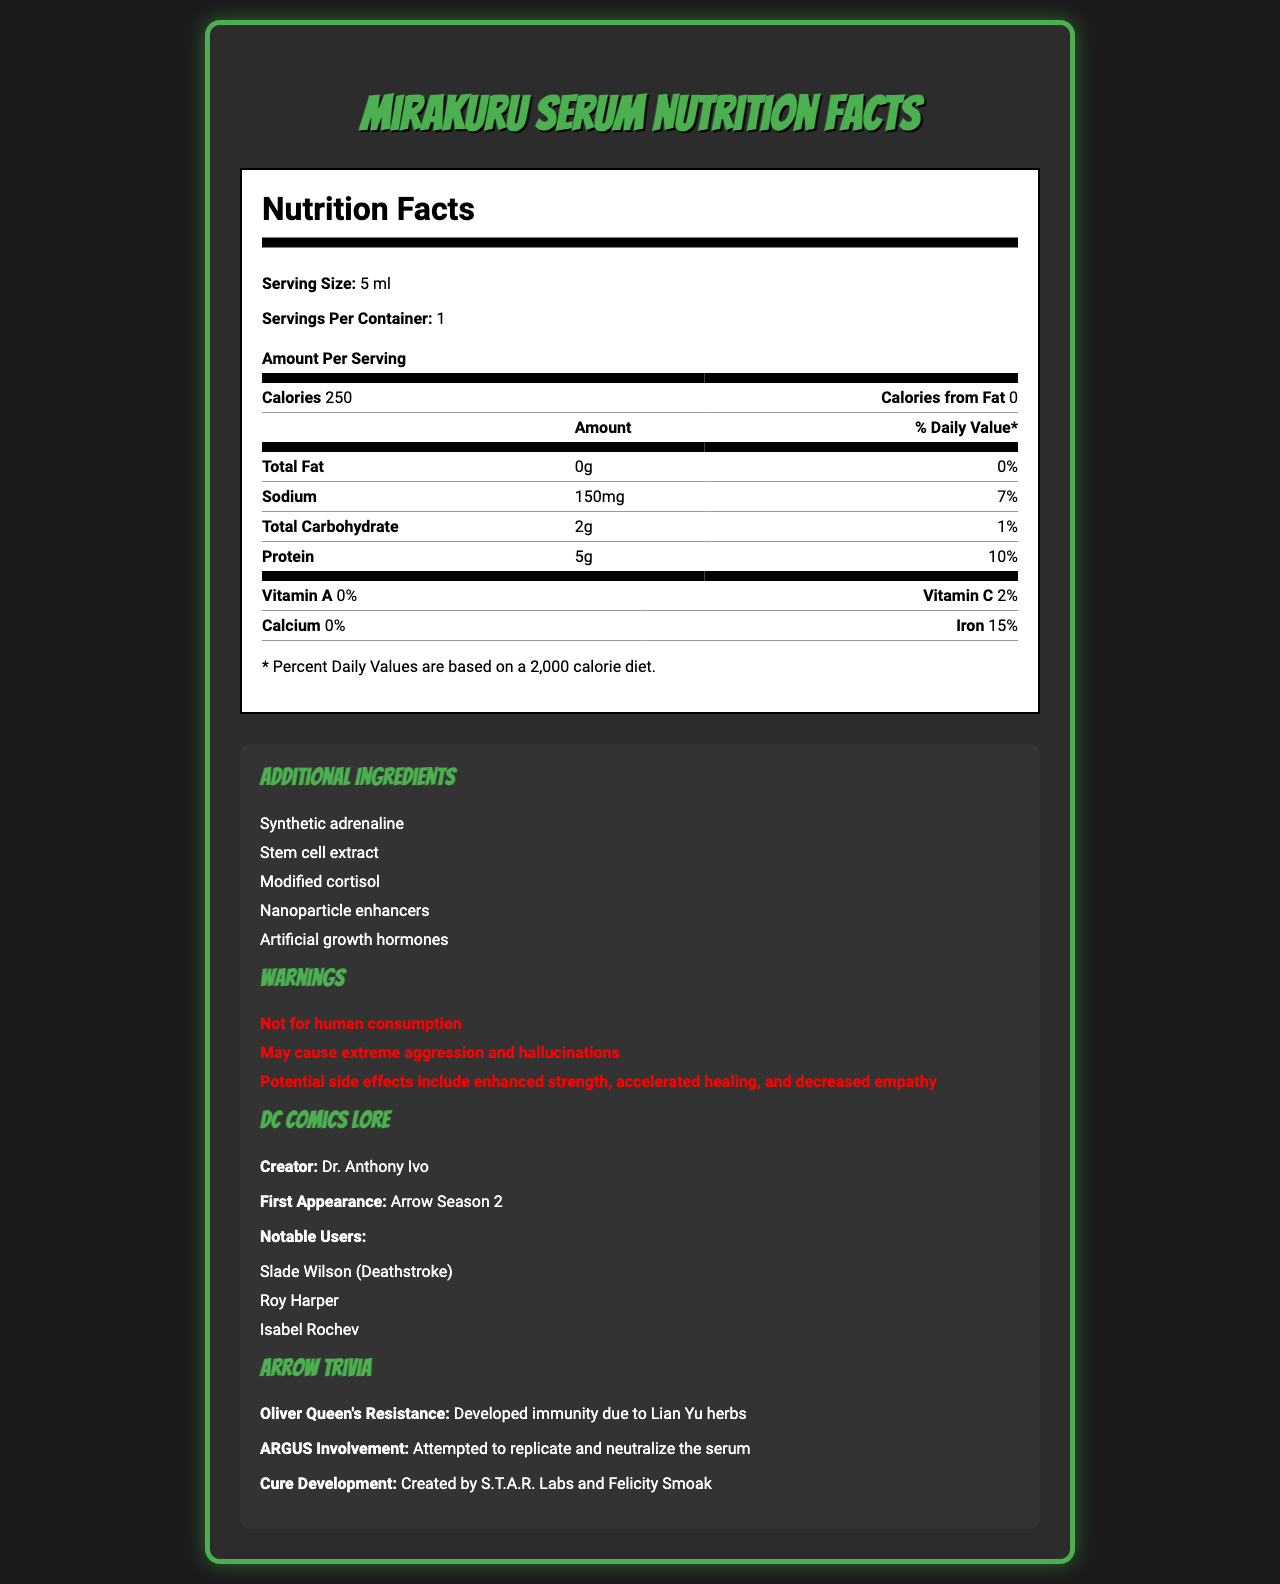what is the serving size of the Mirakuru Serum? The serving size is explicitly listed as "5 ml" in the document.
Answer: 5 ml how many calories are in one serving? The document states that there are 250 calories per serving of the Mirakuru Serum.
Answer: 250 what is the percentage of daily value of sodium? The sodium content is listed as 150mg, which is 7% of the daily value.
Answer: 7% which vitamin has the highest daily value percentage in the Mirakuru Serum, and what is that percentage? The vitamin and mineral list shows Iron with a daily value of 15%, which is the highest among the listed vitamins and minerals.
Answer: Iron, 15% what is the source of Oliver Queen's resistance to the Mirakuru Serum? The Arrow Trivia section states that Oliver Queen developed immunity to the Mirakuru Serum due to Lian Yu herbs.
Answer: Developed immunity due to Lian Yu herbs which side effect is explicitly mentioned as a warning for the Mirakuru Serum? A. Hair loss B. Extreme aggression C. Weight gain One of the warnings listed is "May cause extreme aggression and hallucinations."
Answer: B. Extreme aggression who created the Mirakuru Serum according to DC Comics lore? A. Lex Luthor B. Dr. Anthony Ivo C. Amanda Waller D. Harrison Wells The DC Comics Lore section specifies that the creator is Dr. Anthony Ivo.
Answer: B. Dr. Anthony Ivo which of the following is not an additional ingredient in the Mirakuru Serum? A. Modified cortisol B. Nanoparticle enhancers C. Stem cell extract D. Vitamin D The additional ingredients listed do not include Vitamin D.
Answer: D. Vitamin D is the Mirakuru Serum intended for human consumption? One of the warnings explicitly states, "Not for human consumption."
Answer: No summarize the nutritional and supplemental information provided for the Mirakuru Serum. The document is a comprehensive nutritional analysis of the Mirakuru Serum with detailed percentages of nutrients, additional powerful ingredients, potential side effects, and interesting trivia from the Arrow TV series.
Answer: The document details the nutritional facts of the Mirakuru Serum, including serving size, calories, and macronutrient content. It lists vitamins and minerals, highlighting Iron at 15% daily value and other negligible amounts. Warnings about severe side effects and not for human consumption are mentioned. Additional ingredients include synthetic adrenaline and artificial growth hormones. It also contains trivia relevant to the Arrow TV series and DC Comics lore. what is the main cause of the enhanced strength mentioned in the warnings? The document lists enhanced strength as a potential side effect, but it does not specify which component or ingredient is the primary cause.
Answer: Not enough information 